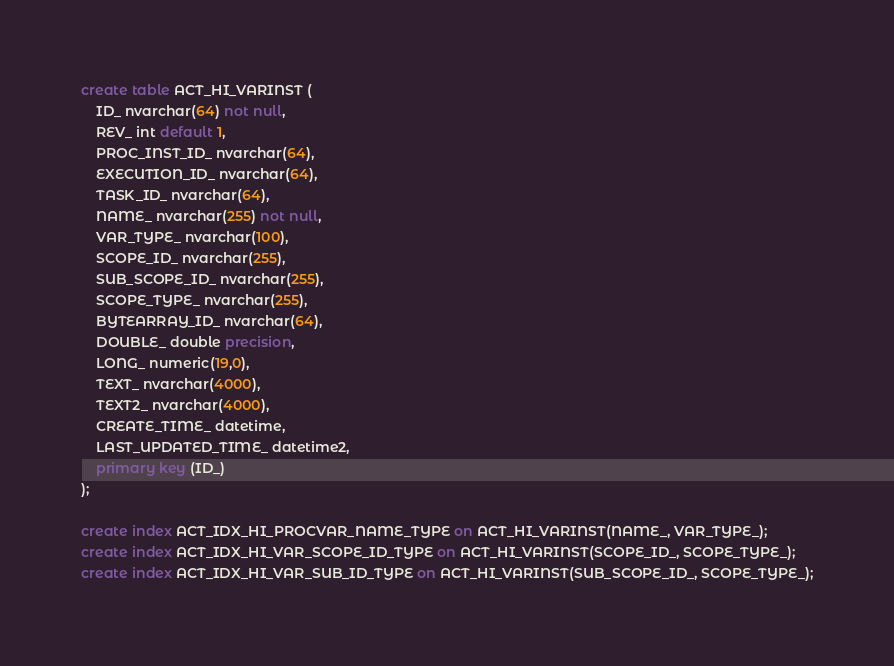Convert code to text. <code><loc_0><loc_0><loc_500><loc_500><_SQL_>create table ACT_HI_VARINST (
    ID_ nvarchar(64) not null,
    REV_ int default 1,
    PROC_INST_ID_ nvarchar(64),
    EXECUTION_ID_ nvarchar(64),
    TASK_ID_ nvarchar(64),
    NAME_ nvarchar(255) not null,
    VAR_TYPE_ nvarchar(100),
    SCOPE_ID_ nvarchar(255),
    SUB_SCOPE_ID_ nvarchar(255),
    SCOPE_TYPE_ nvarchar(255),
    BYTEARRAY_ID_ nvarchar(64),
    DOUBLE_ double precision,
    LONG_ numeric(19,0),
    TEXT_ nvarchar(4000),
    TEXT2_ nvarchar(4000),
    CREATE_TIME_ datetime,
    LAST_UPDATED_TIME_ datetime2,
    primary key (ID_)
);

create index ACT_IDX_HI_PROCVAR_NAME_TYPE on ACT_HI_VARINST(NAME_, VAR_TYPE_);
create index ACT_IDX_HI_VAR_SCOPE_ID_TYPE on ACT_HI_VARINST(SCOPE_ID_, SCOPE_TYPE_);
create index ACT_IDX_HI_VAR_SUB_ID_TYPE on ACT_HI_VARINST(SUB_SCOPE_ID_, SCOPE_TYPE_);
</code> 